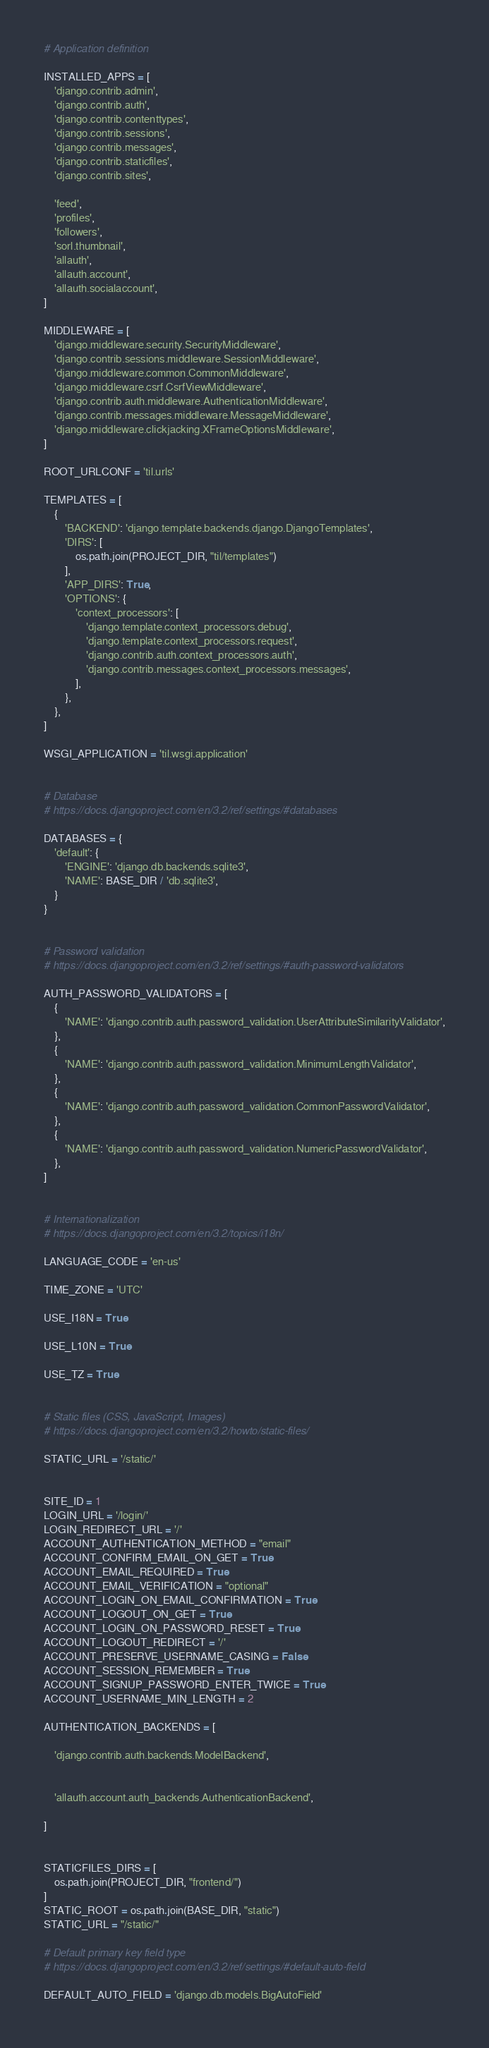<code> <loc_0><loc_0><loc_500><loc_500><_Python_>
# Application definition

INSTALLED_APPS = [
    'django.contrib.admin',
    'django.contrib.auth',
    'django.contrib.contenttypes',
    'django.contrib.sessions',
    'django.contrib.messages',
    'django.contrib.staticfiles',
    'django.contrib.sites',

    'feed',
    'profiles',
    'followers',
    'sorl.thumbnail',
    'allauth',
    'allauth.account',
    'allauth.socialaccount',
]

MIDDLEWARE = [
    'django.middleware.security.SecurityMiddleware',
    'django.contrib.sessions.middleware.SessionMiddleware',
    'django.middleware.common.CommonMiddleware',
    'django.middleware.csrf.CsrfViewMiddleware',
    'django.contrib.auth.middleware.AuthenticationMiddleware',
    'django.contrib.messages.middleware.MessageMiddleware',
    'django.middleware.clickjacking.XFrameOptionsMiddleware',
]

ROOT_URLCONF = 'til.urls'

TEMPLATES = [
    {
        'BACKEND': 'django.template.backends.django.DjangoTemplates',
        'DIRS': [
            os.path.join(PROJECT_DIR, "til/templates")
        ],
        'APP_DIRS': True,
        'OPTIONS': {
            'context_processors': [
                'django.template.context_processors.debug',
                'django.template.context_processors.request',
                'django.contrib.auth.context_processors.auth',
                'django.contrib.messages.context_processors.messages',
            ],
        },
    },
]

WSGI_APPLICATION = 'til.wsgi.application'


# Database
# https://docs.djangoproject.com/en/3.2/ref/settings/#databases

DATABASES = {
    'default': {
        'ENGINE': 'django.db.backends.sqlite3',
        'NAME': BASE_DIR / 'db.sqlite3',
    }
}


# Password validation
# https://docs.djangoproject.com/en/3.2/ref/settings/#auth-password-validators

AUTH_PASSWORD_VALIDATORS = [
    {
        'NAME': 'django.contrib.auth.password_validation.UserAttributeSimilarityValidator',
    },
    {
        'NAME': 'django.contrib.auth.password_validation.MinimumLengthValidator',
    },
    {
        'NAME': 'django.contrib.auth.password_validation.CommonPasswordValidator',
    },
    {
        'NAME': 'django.contrib.auth.password_validation.NumericPasswordValidator',
    },
]


# Internationalization
# https://docs.djangoproject.com/en/3.2/topics/i18n/

LANGUAGE_CODE = 'en-us'

TIME_ZONE = 'UTC'

USE_I18N = True

USE_L10N = True

USE_TZ = True


# Static files (CSS, JavaScript, Images)
# https://docs.djangoproject.com/en/3.2/howto/static-files/

STATIC_URL = '/static/'


SITE_ID = 1
LOGIN_URL = '/login/'
LOGIN_REDIRECT_URL = '/'
ACCOUNT_AUTHENTICATION_METHOD = "email"
ACCOUNT_CONFIRM_EMAIL_ON_GET = True
ACCOUNT_EMAIL_REQUIRED = True
ACCOUNT_EMAIL_VERIFICATION = "optional"
ACCOUNT_LOGIN_ON_EMAIL_CONFIRMATION = True
ACCOUNT_LOGOUT_ON_GET = True
ACCOUNT_LOGIN_ON_PASSWORD_RESET = True
ACCOUNT_LOGOUT_REDIRECT = '/'
ACCOUNT_PRESERVE_USERNAME_CASING = False
ACCOUNT_SESSION_REMEMBER = True
ACCOUNT_SIGNUP_PASSWORD_ENTER_TWICE = True
ACCOUNT_USERNAME_MIN_LENGTH = 2

AUTHENTICATION_BACKENDS = [
    
    'django.contrib.auth.backends.ModelBackend',

    
    'allauth.account.auth_backends.AuthenticationBackend',
    
]


STATICFILES_DIRS = [
    os.path.join(PROJECT_DIR, "frontend/")
]
STATIC_ROOT = os.path.join(BASE_DIR, "static")
STATIC_URL = "/static/"

# Default primary key field type
# https://docs.djangoproject.com/en/3.2/ref/settings/#default-auto-field

DEFAULT_AUTO_FIELD = 'django.db.models.BigAutoField'
</code> 